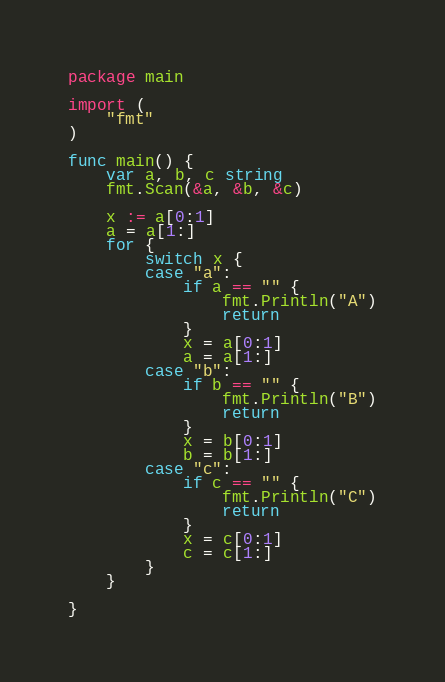<code> <loc_0><loc_0><loc_500><loc_500><_Go_>package main

import (
	"fmt"
)

func main() {
	var a, b, c string
	fmt.Scan(&a, &b, &c)

	x := a[0:1]
	a = a[1:]
	for {
		switch x {
		case "a":
			if a == "" {
				fmt.Println("A")
				return
			}
			x = a[0:1]
			a = a[1:]
		case "b":
			if b == "" {
				fmt.Println("B")
				return
			}
			x = b[0:1]
			b = b[1:]
		case "c":
			if c == "" {
				fmt.Println("C")
				return
			}
			x = c[0:1]
			c = c[1:]
		}
	}

}
</code> 